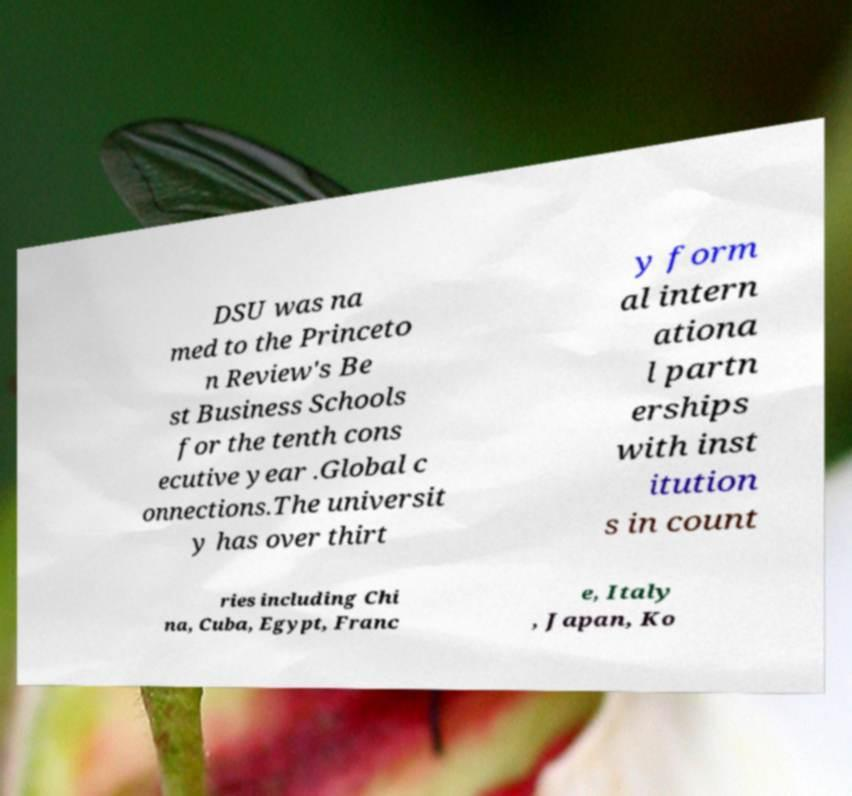Please identify and transcribe the text found in this image. DSU was na med to the Princeto n Review's Be st Business Schools for the tenth cons ecutive year .Global c onnections.The universit y has over thirt y form al intern ationa l partn erships with inst itution s in count ries including Chi na, Cuba, Egypt, Franc e, Italy , Japan, Ko 